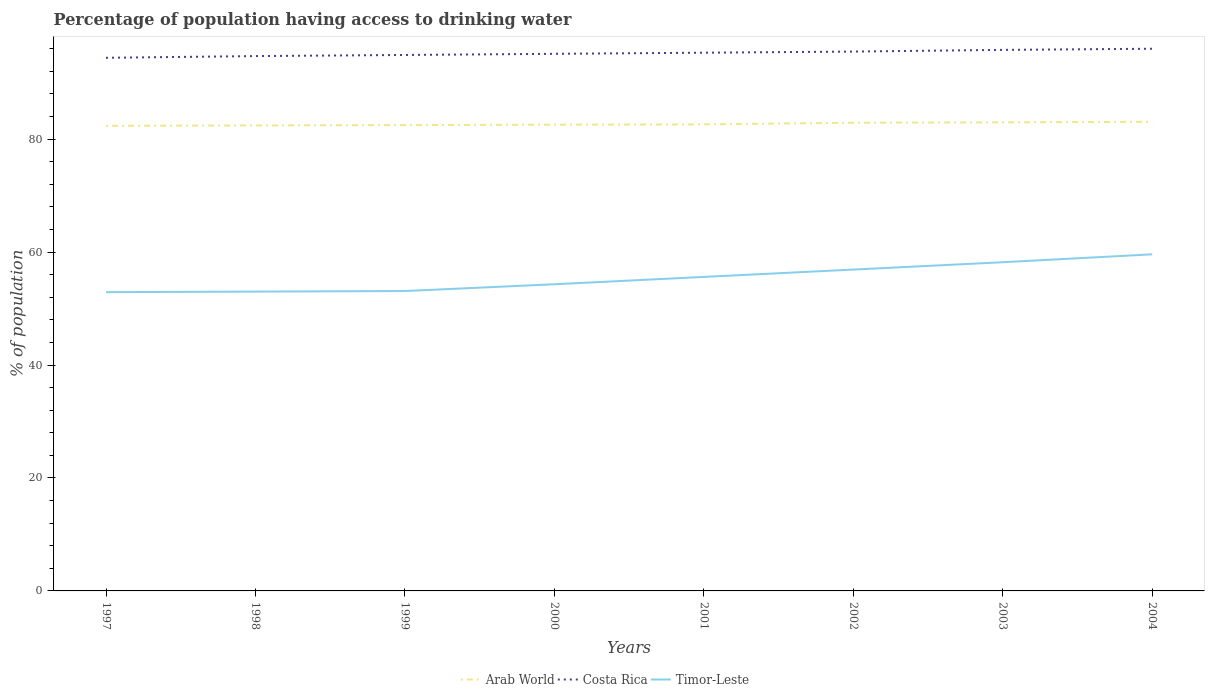Does the line corresponding to Timor-Leste intersect with the line corresponding to Arab World?
Give a very brief answer. No. Across all years, what is the maximum percentage of population having access to drinking water in Arab World?
Your answer should be compact. 82.35. What is the total percentage of population having access to drinking water in Timor-Leste in the graph?
Provide a succinct answer. -1.4. What is the difference between the highest and the second highest percentage of population having access to drinking water in Costa Rica?
Keep it short and to the point. 1.6. What is the difference between the highest and the lowest percentage of population having access to drinking water in Costa Rica?
Make the answer very short. 4. How many lines are there?
Your response must be concise. 3. How many years are there in the graph?
Provide a short and direct response. 8. What is the difference between two consecutive major ticks on the Y-axis?
Your response must be concise. 20. Are the values on the major ticks of Y-axis written in scientific E-notation?
Keep it short and to the point. No. Where does the legend appear in the graph?
Provide a short and direct response. Bottom center. What is the title of the graph?
Your answer should be compact. Percentage of population having access to drinking water. What is the label or title of the X-axis?
Your answer should be very brief. Years. What is the label or title of the Y-axis?
Your response must be concise. % of population. What is the % of population in Arab World in 1997?
Give a very brief answer. 82.35. What is the % of population of Costa Rica in 1997?
Keep it short and to the point. 94.4. What is the % of population of Timor-Leste in 1997?
Offer a very short reply. 52.9. What is the % of population of Arab World in 1998?
Give a very brief answer. 82.42. What is the % of population in Costa Rica in 1998?
Give a very brief answer. 94.7. What is the % of population in Timor-Leste in 1998?
Give a very brief answer. 53. What is the % of population of Arab World in 1999?
Offer a very short reply. 82.48. What is the % of population of Costa Rica in 1999?
Make the answer very short. 94.9. What is the % of population of Timor-Leste in 1999?
Your response must be concise. 53.1. What is the % of population in Arab World in 2000?
Ensure brevity in your answer.  82.55. What is the % of population in Costa Rica in 2000?
Make the answer very short. 95.1. What is the % of population in Timor-Leste in 2000?
Ensure brevity in your answer.  54.3. What is the % of population of Arab World in 2001?
Ensure brevity in your answer.  82.61. What is the % of population of Costa Rica in 2001?
Provide a short and direct response. 95.3. What is the % of population in Timor-Leste in 2001?
Give a very brief answer. 55.6. What is the % of population in Arab World in 2002?
Offer a terse response. 82.9. What is the % of population of Costa Rica in 2002?
Keep it short and to the point. 95.5. What is the % of population of Timor-Leste in 2002?
Your answer should be compact. 56.9. What is the % of population in Arab World in 2003?
Your response must be concise. 82.97. What is the % of population in Costa Rica in 2003?
Provide a succinct answer. 95.8. What is the % of population of Timor-Leste in 2003?
Your answer should be compact. 58.2. What is the % of population of Arab World in 2004?
Make the answer very short. 83.07. What is the % of population in Costa Rica in 2004?
Make the answer very short. 96. What is the % of population in Timor-Leste in 2004?
Provide a short and direct response. 59.6. Across all years, what is the maximum % of population of Arab World?
Your response must be concise. 83.07. Across all years, what is the maximum % of population in Costa Rica?
Offer a terse response. 96. Across all years, what is the maximum % of population in Timor-Leste?
Give a very brief answer. 59.6. Across all years, what is the minimum % of population in Arab World?
Make the answer very short. 82.35. Across all years, what is the minimum % of population in Costa Rica?
Make the answer very short. 94.4. Across all years, what is the minimum % of population in Timor-Leste?
Offer a very short reply. 52.9. What is the total % of population of Arab World in the graph?
Provide a succinct answer. 661.35. What is the total % of population of Costa Rica in the graph?
Make the answer very short. 761.7. What is the total % of population in Timor-Leste in the graph?
Give a very brief answer. 443.6. What is the difference between the % of population in Arab World in 1997 and that in 1998?
Your answer should be compact. -0.07. What is the difference between the % of population in Costa Rica in 1997 and that in 1998?
Offer a terse response. -0.3. What is the difference between the % of population of Arab World in 1997 and that in 1999?
Your answer should be very brief. -0.13. What is the difference between the % of population of Arab World in 1997 and that in 2000?
Provide a succinct answer. -0.2. What is the difference between the % of population of Costa Rica in 1997 and that in 2000?
Your response must be concise. -0.7. What is the difference between the % of population in Timor-Leste in 1997 and that in 2000?
Offer a very short reply. -1.4. What is the difference between the % of population in Arab World in 1997 and that in 2001?
Offer a terse response. -0.26. What is the difference between the % of population in Costa Rica in 1997 and that in 2001?
Your answer should be compact. -0.9. What is the difference between the % of population in Timor-Leste in 1997 and that in 2001?
Provide a succinct answer. -2.7. What is the difference between the % of population in Arab World in 1997 and that in 2002?
Offer a terse response. -0.55. What is the difference between the % of population of Timor-Leste in 1997 and that in 2002?
Offer a terse response. -4. What is the difference between the % of population of Arab World in 1997 and that in 2003?
Give a very brief answer. -0.62. What is the difference between the % of population of Timor-Leste in 1997 and that in 2003?
Your response must be concise. -5.3. What is the difference between the % of population in Arab World in 1997 and that in 2004?
Your answer should be very brief. -0.72. What is the difference between the % of population in Arab World in 1998 and that in 1999?
Your response must be concise. -0.06. What is the difference between the % of population in Costa Rica in 1998 and that in 1999?
Give a very brief answer. -0.2. What is the difference between the % of population of Timor-Leste in 1998 and that in 1999?
Your answer should be very brief. -0.1. What is the difference between the % of population of Arab World in 1998 and that in 2000?
Provide a short and direct response. -0.13. What is the difference between the % of population in Costa Rica in 1998 and that in 2000?
Your answer should be very brief. -0.4. What is the difference between the % of population in Arab World in 1998 and that in 2001?
Your response must be concise. -0.19. What is the difference between the % of population of Costa Rica in 1998 and that in 2001?
Make the answer very short. -0.6. What is the difference between the % of population of Arab World in 1998 and that in 2002?
Offer a terse response. -0.48. What is the difference between the % of population of Costa Rica in 1998 and that in 2002?
Offer a very short reply. -0.8. What is the difference between the % of population of Timor-Leste in 1998 and that in 2002?
Offer a terse response. -3.9. What is the difference between the % of population in Arab World in 1998 and that in 2003?
Provide a short and direct response. -0.55. What is the difference between the % of population in Timor-Leste in 1998 and that in 2003?
Provide a succinct answer. -5.2. What is the difference between the % of population of Arab World in 1998 and that in 2004?
Keep it short and to the point. -0.65. What is the difference between the % of population of Costa Rica in 1998 and that in 2004?
Offer a very short reply. -1.3. What is the difference between the % of population in Timor-Leste in 1998 and that in 2004?
Make the answer very short. -6.6. What is the difference between the % of population in Arab World in 1999 and that in 2000?
Offer a very short reply. -0.07. What is the difference between the % of population in Costa Rica in 1999 and that in 2000?
Provide a short and direct response. -0.2. What is the difference between the % of population of Arab World in 1999 and that in 2001?
Provide a short and direct response. -0.13. What is the difference between the % of population in Arab World in 1999 and that in 2002?
Provide a succinct answer. -0.42. What is the difference between the % of population of Arab World in 1999 and that in 2003?
Ensure brevity in your answer.  -0.49. What is the difference between the % of population in Costa Rica in 1999 and that in 2003?
Offer a very short reply. -0.9. What is the difference between the % of population of Arab World in 1999 and that in 2004?
Ensure brevity in your answer.  -0.59. What is the difference between the % of population in Costa Rica in 1999 and that in 2004?
Provide a short and direct response. -1.1. What is the difference between the % of population in Timor-Leste in 1999 and that in 2004?
Offer a terse response. -6.5. What is the difference between the % of population in Arab World in 2000 and that in 2001?
Your answer should be very brief. -0.06. What is the difference between the % of population in Arab World in 2000 and that in 2002?
Offer a very short reply. -0.35. What is the difference between the % of population in Costa Rica in 2000 and that in 2002?
Provide a short and direct response. -0.4. What is the difference between the % of population in Timor-Leste in 2000 and that in 2002?
Provide a succinct answer. -2.6. What is the difference between the % of population in Arab World in 2000 and that in 2003?
Offer a very short reply. -0.42. What is the difference between the % of population in Arab World in 2000 and that in 2004?
Give a very brief answer. -0.51. What is the difference between the % of population in Timor-Leste in 2000 and that in 2004?
Ensure brevity in your answer.  -5.3. What is the difference between the % of population in Arab World in 2001 and that in 2002?
Your answer should be compact. -0.29. What is the difference between the % of population of Timor-Leste in 2001 and that in 2002?
Your answer should be compact. -1.3. What is the difference between the % of population of Arab World in 2001 and that in 2003?
Your response must be concise. -0.36. What is the difference between the % of population of Costa Rica in 2001 and that in 2003?
Make the answer very short. -0.5. What is the difference between the % of population in Timor-Leste in 2001 and that in 2003?
Give a very brief answer. -2.6. What is the difference between the % of population of Arab World in 2001 and that in 2004?
Offer a terse response. -0.46. What is the difference between the % of population of Arab World in 2002 and that in 2003?
Offer a terse response. -0.07. What is the difference between the % of population in Timor-Leste in 2002 and that in 2003?
Your answer should be compact. -1.3. What is the difference between the % of population of Arab World in 2002 and that in 2004?
Your answer should be very brief. -0.17. What is the difference between the % of population in Arab World in 2003 and that in 2004?
Offer a very short reply. -0.1. What is the difference between the % of population in Timor-Leste in 2003 and that in 2004?
Ensure brevity in your answer.  -1.4. What is the difference between the % of population in Arab World in 1997 and the % of population in Costa Rica in 1998?
Provide a short and direct response. -12.35. What is the difference between the % of population in Arab World in 1997 and the % of population in Timor-Leste in 1998?
Give a very brief answer. 29.35. What is the difference between the % of population in Costa Rica in 1997 and the % of population in Timor-Leste in 1998?
Provide a succinct answer. 41.4. What is the difference between the % of population in Arab World in 1997 and the % of population in Costa Rica in 1999?
Keep it short and to the point. -12.55. What is the difference between the % of population of Arab World in 1997 and the % of population of Timor-Leste in 1999?
Make the answer very short. 29.25. What is the difference between the % of population in Costa Rica in 1997 and the % of population in Timor-Leste in 1999?
Your answer should be compact. 41.3. What is the difference between the % of population in Arab World in 1997 and the % of population in Costa Rica in 2000?
Your answer should be compact. -12.75. What is the difference between the % of population in Arab World in 1997 and the % of population in Timor-Leste in 2000?
Offer a very short reply. 28.05. What is the difference between the % of population of Costa Rica in 1997 and the % of population of Timor-Leste in 2000?
Your answer should be very brief. 40.1. What is the difference between the % of population in Arab World in 1997 and the % of population in Costa Rica in 2001?
Your answer should be compact. -12.95. What is the difference between the % of population of Arab World in 1997 and the % of population of Timor-Leste in 2001?
Give a very brief answer. 26.75. What is the difference between the % of population of Costa Rica in 1997 and the % of population of Timor-Leste in 2001?
Ensure brevity in your answer.  38.8. What is the difference between the % of population in Arab World in 1997 and the % of population in Costa Rica in 2002?
Ensure brevity in your answer.  -13.15. What is the difference between the % of population of Arab World in 1997 and the % of population of Timor-Leste in 2002?
Your answer should be compact. 25.45. What is the difference between the % of population in Costa Rica in 1997 and the % of population in Timor-Leste in 2002?
Provide a succinct answer. 37.5. What is the difference between the % of population of Arab World in 1997 and the % of population of Costa Rica in 2003?
Ensure brevity in your answer.  -13.45. What is the difference between the % of population of Arab World in 1997 and the % of population of Timor-Leste in 2003?
Your response must be concise. 24.15. What is the difference between the % of population in Costa Rica in 1997 and the % of population in Timor-Leste in 2003?
Provide a succinct answer. 36.2. What is the difference between the % of population in Arab World in 1997 and the % of population in Costa Rica in 2004?
Your answer should be compact. -13.65. What is the difference between the % of population in Arab World in 1997 and the % of population in Timor-Leste in 2004?
Your response must be concise. 22.75. What is the difference between the % of population of Costa Rica in 1997 and the % of population of Timor-Leste in 2004?
Your answer should be compact. 34.8. What is the difference between the % of population in Arab World in 1998 and the % of population in Costa Rica in 1999?
Your response must be concise. -12.48. What is the difference between the % of population in Arab World in 1998 and the % of population in Timor-Leste in 1999?
Keep it short and to the point. 29.32. What is the difference between the % of population in Costa Rica in 1998 and the % of population in Timor-Leste in 1999?
Keep it short and to the point. 41.6. What is the difference between the % of population of Arab World in 1998 and the % of population of Costa Rica in 2000?
Ensure brevity in your answer.  -12.68. What is the difference between the % of population in Arab World in 1998 and the % of population in Timor-Leste in 2000?
Make the answer very short. 28.12. What is the difference between the % of population of Costa Rica in 1998 and the % of population of Timor-Leste in 2000?
Your answer should be very brief. 40.4. What is the difference between the % of population in Arab World in 1998 and the % of population in Costa Rica in 2001?
Provide a short and direct response. -12.88. What is the difference between the % of population of Arab World in 1998 and the % of population of Timor-Leste in 2001?
Make the answer very short. 26.82. What is the difference between the % of population of Costa Rica in 1998 and the % of population of Timor-Leste in 2001?
Keep it short and to the point. 39.1. What is the difference between the % of population of Arab World in 1998 and the % of population of Costa Rica in 2002?
Offer a very short reply. -13.08. What is the difference between the % of population in Arab World in 1998 and the % of population in Timor-Leste in 2002?
Ensure brevity in your answer.  25.52. What is the difference between the % of population in Costa Rica in 1998 and the % of population in Timor-Leste in 2002?
Keep it short and to the point. 37.8. What is the difference between the % of population in Arab World in 1998 and the % of population in Costa Rica in 2003?
Keep it short and to the point. -13.38. What is the difference between the % of population in Arab World in 1998 and the % of population in Timor-Leste in 2003?
Give a very brief answer. 24.22. What is the difference between the % of population in Costa Rica in 1998 and the % of population in Timor-Leste in 2003?
Your response must be concise. 36.5. What is the difference between the % of population in Arab World in 1998 and the % of population in Costa Rica in 2004?
Provide a short and direct response. -13.58. What is the difference between the % of population in Arab World in 1998 and the % of population in Timor-Leste in 2004?
Give a very brief answer. 22.82. What is the difference between the % of population in Costa Rica in 1998 and the % of population in Timor-Leste in 2004?
Provide a succinct answer. 35.1. What is the difference between the % of population of Arab World in 1999 and the % of population of Costa Rica in 2000?
Your response must be concise. -12.62. What is the difference between the % of population in Arab World in 1999 and the % of population in Timor-Leste in 2000?
Provide a short and direct response. 28.18. What is the difference between the % of population in Costa Rica in 1999 and the % of population in Timor-Leste in 2000?
Your answer should be compact. 40.6. What is the difference between the % of population of Arab World in 1999 and the % of population of Costa Rica in 2001?
Ensure brevity in your answer.  -12.82. What is the difference between the % of population of Arab World in 1999 and the % of population of Timor-Leste in 2001?
Keep it short and to the point. 26.88. What is the difference between the % of population of Costa Rica in 1999 and the % of population of Timor-Leste in 2001?
Provide a short and direct response. 39.3. What is the difference between the % of population of Arab World in 1999 and the % of population of Costa Rica in 2002?
Your answer should be compact. -13.02. What is the difference between the % of population of Arab World in 1999 and the % of population of Timor-Leste in 2002?
Your answer should be very brief. 25.58. What is the difference between the % of population of Costa Rica in 1999 and the % of population of Timor-Leste in 2002?
Your answer should be compact. 38. What is the difference between the % of population in Arab World in 1999 and the % of population in Costa Rica in 2003?
Give a very brief answer. -13.32. What is the difference between the % of population of Arab World in 1999 and the % of population of Timor-Leste in 2003?
Keep it short and to the point. 24.28. What is the difference between the % of population in Costa Rica in 1999 and the % of population in Timor-Leste in 2003?
Your answer should be very brief. 36.7. What is the difference between the % of population in Arab World in 1999 and the % of population in Costa Rica in 2004?
Give a very brief answer. -13.52. What is the difference between the % of population of Arab World in 1999 and the % of population of Timor-Leste in 2004?
Provide a short and direct response. 22.88. What is the difference between the % of population in Costa Rica in 1999 and the % of population in Timor-Leste in 2004?
Give a very brief answer. 35.3. What is the difference between the % of population in Arab World in 2000 and the % of population in Costa Rica in 2001?
Keep it short and to the point. -12.75. What is the difference between the % of population in Arab World in 2000 and the % of population in Timor-Leste in 2001?
Provide a short and direct response. 26.95. What is the difference between the % of population in Costa Rica in 2000 and the % of population in Timor-Leste in 2001?
Give a very brief answer. 39.5. What is the difference between the % of population in Arab World in 2000 and the % of population in Costa Rica in 2002?
Offer a terse response. -12.95. What is the difference between the % of population of Arab World in 2000 and the % of population of Timor-Leste in 2002?
Make the answer very short. 25.65. What is the difference between the % of population in Costa Rica in 2000 and the % of population in Timor-Leste in 2002?
Provide a short and direct response. 38.2. What is the difference between the % of population in Arab World in 2000 and the % of population in Costa Rica in 2003?
Your answer should be compact. -13.25. What is the difference between the % of population of Arab World in 2000 and the % of population of Timor-Leste in 2003?
Ensure brevity in your answer.  24.35. What is the difference between the % of population in Costa Rica in 2000 and the % of population in Timor-Leste in 2003?
Give a very brief answer. 36.9. What is the difference between the % of population in Arab World in 2000 and the % of population in Costa Rica in 2004?
Your answer should be compact. -13.45. What is the difference between the % of population of Arab World in 2000 and the % of population of Timor-Leste in 2004?
Your response must be concise. 22.95. What is the difference between the % of population in Costa Rica in 2000 and the % of population in Timor-Leste in 2004?
Ensure brevity in your answer.  35.5. What is the difference between the % of population of Arab World in 2001 and the % of population of Costa Rica in 2002?
Your response must be concise. -12.89. What is the difference between the % of population in Arab World in 2001 and the % of population in Timor-Leste in 2002?
Ensure brevity in your answer.  25.71. What is the difference between the % of population in Costa Rica in 2001 and the % of population in Timor-Leste in 2002?
Offer a terse response. 38.4. What is the difference between the % of population of Arab World in 2001 and the % of population of Costa Rica in 2003?
Give a very brief answer. -13.19. What is the difference between the % of population of Arab World in 2001 and the % of population of Timor-Leste in 2003?
Your answer should be compact. 24.41. What is the difference between the % of population of Costa Rica in 2001 and the % of population of Timor-Leste in 2003?
Provide a succinct answer. 37.1. What is the difference between the % of population of Arab World in 2001 and the % of population of Costa Rica in 2004?
Make the answer very short. -13.39. What is the difference between the % of population in Arab World in 2001 and the % of population in Timor-Leste in 2004?
Ensure brevity in your answer.  23.01. What is the difference between the % of population in Costa Rica in 2001 and the % of population in Timor-Leste in 2004?
Your response must be concise. 35.7. What is the difference between the % of population in Arab World in 2002 and the % of population in Costa Rica in 2003?
Your answer should be compact. -12.9. What is the difference between the % of population of Arab World in 2002 and the % of population of Timor-Leste in 2003?
Offer a terse response. 24.7. What is the difference between the % of population in Costa Rica in 2002 and the % of population in Timor-Leste in 2003?
Provide a succinct answer. 37.3. What is the difference between the % of population of Arab World in 2002 and the % of population of Costa Rica in 2004?
Make the answer very short. -13.1. What is the difference between the % of population of Arab World in 2002 and the % of population of Timor-Leste in 2004?
Provide a short and direct response. 23.3. What is the difference between the % of population of Costa Rica in 2002 and the % of population of Timor-Leste in 2004?
Provide a short and direct response. 35.9. What is the difference between the % of population of Arab World in 2003 and the % of population of Costa Rica in 2004?
Your answer should be compact. -13.03. What is the difference between the % of population of Arab World in 2003 and the % of population of Timor-Leste in 2004?
Make the answer very short. 23.37. What is the difference between the % of population in Costa Rica in 2003 and the % of population in Timor-Leste in 2004?
Keep it short and to the point. 36.2. What is the average % of population in Arab World per year?
Your answer should be compact. 82.67. What is the average % of population in Costa Rica per year?
Provide a short and direct response. 95.21. What is the average % of population in Timor-Leste per year?
Your answer should be compact. 55.45. In the year 1997, what is the difference between the % of population of Arab World and % of population of Costa Rica?
Offer a terse response. -12.05. In the year 1997, what is the difference between the % of population of Arab World and % of population of Timor-Leste?
Offer a terse response. 29.45. In the year 1997, what is the difference between the % of population of Costa Rica and % of population of Timor-Leste?
Provide a short and direct response. 41.5. In the year 1998, what is the difference between the % of population in Arab World and % of population in Costa Rica?
Give a very brief answer. -12.28. In the year 1998, what is the difference between the % of population in Arab World and % of population in Timor-Leste?
Your answer should be compact. 29.42. In the year 1998, what is the difference between the % of population of Costa Rica and % of population of Timor-Leste?
Your answer should be compact. 41.7. In the year 1999, what is the difference between the % of population of Arab World and % of population of Costa Rica?
Give a very brief answer. -12.42. In the year 1999, what is the difference between the % of population in Arab World and % of population in Timor-Leste?
Provide a succinct answer. 29.38. In the year 1999, what is the difference between the % of population in Costa Rica and % of population in Timor-Leste?
Ensure brevity in your answer.  41.8. In the year 2000, what is the difference between the % of population of Arab World and % of population of Costa Rica?
Provide a succinct answer. -12.55. In the year 2000, what is the difference between the % of population of Arab World and % of population of Timor-Leste?
Your answer should be very brief. 28.25. In the year 2000, what is the difference between the % of population in Costa Rica and % of population in Timor-Leste?
Your answer should be compact. 40.8. In the year 2001, what is the difference between the % of population in Arab World and % of population in Costa Rica?
Offer a very short reply. -12.69. In the year 2001, what is the difference between the % of population in Arab World and % of population in Timor-Leste?
Make the answer very short. 27.01. In the year 2001, what is the difference between the % of population of Costa Rica and % of population of Timor-Leste?
Make the answer very short. 39.7. In the year 2002, what is the difference between the % of population in Arab World and % of population in Costa Rica?
Your answer should be very brief. -12.6. In the year 2002, what is the difference between the % of population in Arab World and % of population in Timor-Leste?
Your response must be concise. 26. In the year 2002, what is the difference between the % of population in Costa Rica and % of population in Timor-Leste?
Your answer should be compact. 38.6. In the year 2003, what is the difference between the % of population in Arab World and % of population in Costa Rica?
Provide a succinct answer. -12.83. In the year 2003, what is the difference between the % of population of Arab World and % of population of Timor-Leste?
Keep it short and to the point. 24.77. In the year 2003, what is the difference between the % of population in Costa Rica and % of population in Timor-Leste?
Provide a short and direct response. 37.6. In the year 2004, what is the difference between the % of population of Arab World and % of population of Costa Rica?
Provide a succinct answer. -12.93. In the year 2004, what is the difference between the % of population of Arab World and % of population of Timor-Leste?
Offer a very short reply. 23.47. In the year 2004, what is the difference between the % of population of Costa Rica and % of population of Timor-Leste?
Your answer should be very brief. 36.4. What is the ratio of the % of population of Timor-Leste in 1997 to that in 1998?
Give a very brief answer. 1. What is the ratio of the % of population in Costa Rica in 1997 to that in 1999?
Your response must be concise. 0.99. What is the ratio of the % of population in Arab World in 1997 to that in 2000?
Your answer should be compact. 1. What is the ratio of the % of population of Costa Rica in 1997 to that in 2000?
Keep it short and to the point. 0.99. What is the ratio of the % of population of Timor-Leste in 1997 to that in 2000?
Ensure brevity in your answer.  0.97. What is the ratio of the % of population in Costa Rica in 1997 to that in 2001?
Keep it short and to the point. 0.99. What is the ratio of the % of population in Timor-Leste in 1997 to that in 2001?
Provide a succinct answer. 0.95. What is the ratio of the % of population in Arab World in 1997 to that in 2002?
Keep it short and to the point. 0.99. What is the ratio of the % of population of Costa Rica in 1997 to that in 2002?
Provide a succinct answer. 0.99. What is the ratio of the % of population of Timor-Leste in 1997 to that in 2002?
Offer a terse response. 0.93. What is the ratio of the % of population of Costa Rica in 1997 to that in 2003?
Provide a succinct answer. 0.99. What is the ratio of the % of population of Timor-Leste in 1997 to that in 2003?
Ensure brevity in your answer.  0.91. What is the ratio of the % of population of Arab World in 1997 to that in 2004?
Give a very brief answer. 0.99. What is the ratio of the % of population of Costa Rica in 1997 to that in 2004?
Give a very brief answer. 0.98. What is the ratio of the % of population of Timor-Leste in 1997 to that in 2004?
Give a very brief answer. 0.89. What is the ratio of the % of population in Costa Rica in 1998 to that in 1999?
Offer a terse response. 1. What is the ratio of the % of population of Timor-Leste in 1998 to that in 1999?
Keep it short and to the point. 1. What is the ratio of the % of population in Arab World in 1998 to that in 2000?
Ensure brevity in your answer.  1. What is the ratio of the % of population of Costa Rica in 1998 to that in 2000?
Offer a terse response. 1. What is the ratio of the % of population of Timor-Leste in 1998 to that in 2000?
Keep it short and to the point. 0.98. What is the ratio of the % of population in Costa Rica in 1998 to that in 2001?
Give a very brief answer. 0.99. What is the ratio of the % of population in Timor-Leste in 1998 to that in 2001?
Give a very brief answer. 0.95. What is the ratio of the % of population in Costa Rica in 1998 to that in 2002?
Your answer should be compact. 0.99. What is the ratio of the % of population in Timor-Leste in 1998 to that in 2002?
Offer a terse response. 0.93. What is the ratio of the % of population of Timor-Leste in 1998 to that in 2003?
Your answer should be compact. 0.91. What is the ratio of the % of population in Arab World in 1998 to that in 2004?
Provide a short and direct response. 0.99. What is the ratio of the % of population in Costa Rica in 1998 to that in 2004?
Your response must be concise. 0.99. What is the ratio of the % of population of Timor-Leste in 1998 to that in 2004?
Provide a short and direct response. 0.89. What is the ratio of the % of population of Arab World in 1999 to that in 2000?
Offer a very short reply. 1. What is the ratio of the % of population in Timor-Leste in 1999 to that in 2000?
Provide a short and direct response. 0.98. What is the ratio of the % of population in Costa Rica in 1999 to that in 2001?
Provide a succinct answer. 1. What is the ratio of the % of population of Timor-Leste in 1999 to that in 2001?
Provide a short and direct response. 0.95. What is the ratio of the % of population in Arab World in 1999 to that in 2002?
Your response must be concise. 0.99. What is the ratio of the % of population in Costa Rica in 1999 to that in 2002?
Provide a succinct answer. 0.99. What is the ratio of the % of population in Timor-Leste in 1999 to that in 2002?
Offer a very short reply. 0.93. What is the ratio of the % of population of Arab World in 1999 to that in 2003?
Ensure brevity in your answer.  0.99. What is the ratio of the % of population in Costa Rica in 1999 to that in 2003?
Ensure brevity in your answer.  0.99. What is the ratio of the % of population of Timor-Leste in 1999 to that in 2003?
Offer a terse response. 0.91. What is the ratio of the % of population of Arab World in 1999 to that in 2004?
Make the answer very short. 0.99. What is the ratio of the % of population of Timor-Leste in 1999 to that in 2004?
Ensure brevity in your answer.  0.89. What is the ratio of the % of population of Costa Rica in 2000 to that in 2001?
Give a very brief answer. 1. What is the ratio of the % of population of Timor-Leste in 2000 to that in 2001?
Provide a succinct answer. 0.98. What is the ratio of the % of population of Arab World in 2000 to that in 2002?
Provide a succinct answer. 1. What is the ratio of the % of population of Costa Rica in 2000 to that in 2002?
Your answer should be very brief. 1. What is the ratio of the % of population of Timor-Leste in 2000 to that in 2002?
Your response must be concise. 0.95. What is the ratio of the % of population in Arab World in 2000 to that in 2003?
Ensure brevity in your answer.  0.99. What is the ratio of the % of population in Timor-Leste in 2000 to that in 2003?
Offer a very short reply. 0.93. What is the ratio of the % of population of Costa Rica in 2000 to that in 2004?
Keep it short and to the point. 0.99. What is the ratio of the % of population of Timor-Leste in 2000 to that in 2004?
Provide a short and direct response. 0.91. What is the ratio of the % of population of Arab World in 2001 to that in 2002?
Keep it short and to the point. 1. What is the ratio of the % of population in Timor-Leste in 2001 to that in 2002?
Offer a terse response. 0.98. What is the ratio of the % of population of Arab World in 2001 to that in 2003?
Give a very brief answer. 1. What is the ratio of the % of population of Costa Rica in 2001 to that in 2003?
Offer a very short reply. 0.99. What is the ratio of the % of population in Timor-Leste in 2001 to that in 2003?
Keep it short and to the point. 0.96. What is the ratio of the % of population in Costa Rica in 2001 to that in 2004?
Your answer should be very brief. 0.99. What is the ratio of the % of population of Timor-Leste in 2001 to that in 2004?
Provide a short and direct response. 0.93. What is the ratio of the % of population of Costa Rica in 2002 to that in 2003?
Offer a terse response. 1. What is the ratio of the % of population in Timor-Leste in 2002 to that in 2003?
Keep it short and to the point. 0.98. What is the ratio of the % of population of Costa Rica in 2002 to that in 2004?
Give a very brief answer. 0.99. What is the ratio of the % of population of Timor-Leste in 2002 to that in 2004?
Give a very brief answer. 0.95. What is the ratio of the % of population in Arab World in 2003 to that in 2004?
Ensure brevity in your answer.  1. What is the ratio of the % of population of Costa Rica in 2003 to that in 2004?
Offer a very short reply. 1. What is the ratio of the % of population of Timor-Leste in 2003 to that in 2004?
Offer a very short reply. 0.98. What is the difference between the highest and the second highest % of population of Arab World?
Your answer should be very brief. 0.1. What is the difference between the highest and the second highest % of population in Costa Rica?
Your response must be concise. 0.2. What is the difference between the highest and the lowest % of population in Arab World?
Your response must be concise. 0.72. What is the difference between the highest and the lowest % of population of Costa Rica?
Ensure brevity in your answer.  1.6. What is the difference between the highest and the lowest % of population of Timor-Leste?
Provide a succinct answer. 6.7. 